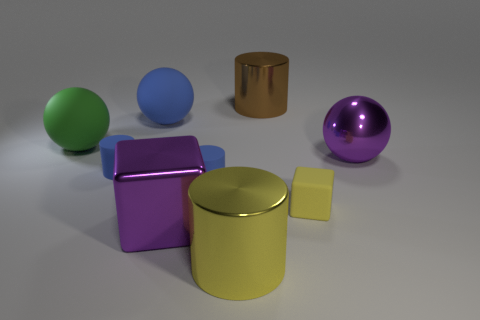There is a metallic object that is to the left of the large metal cylinder in front of the green matte ball that is behind the large yellow metal thing; how big is it?
Make the answer very short. Large. Does the yellow cube have the same size as the brown object?
Make the answer very short. No. The big cylinder that is right of the big metal cylinder in front of the big brown thing is made of what material?
Your response must be concise. Metal. There is a purple thing that is to the right of the brown metallic thing; is its shape the same as the big blue rubber object in front of the large brown thing?
Your answer should be compact. Yes. Are there an equal number of rubber objects in front of the yellow cube and big yellow things?
Your answer should be compact. No. Are there any tiny blue cylinders that are on the left side of the purple object left of the metallic ball?
Your response must be concise. Yes. Are there any other things of the same color as the big block?
Your answer should be compact. Yes. Is the material of the small object that is to the left of the big cube the same as the large blue sphere?
Your answer should be compact. Yes. Are there the same number of small blue objects that are behind the large blue sphere and brown objects that are in front of the big green thing?
Your answer should be compact. Yes. What is the size of the purple metallic object behind the small thing on the right side of the large brown shiny thing?
Give a very brief answer. Large. 